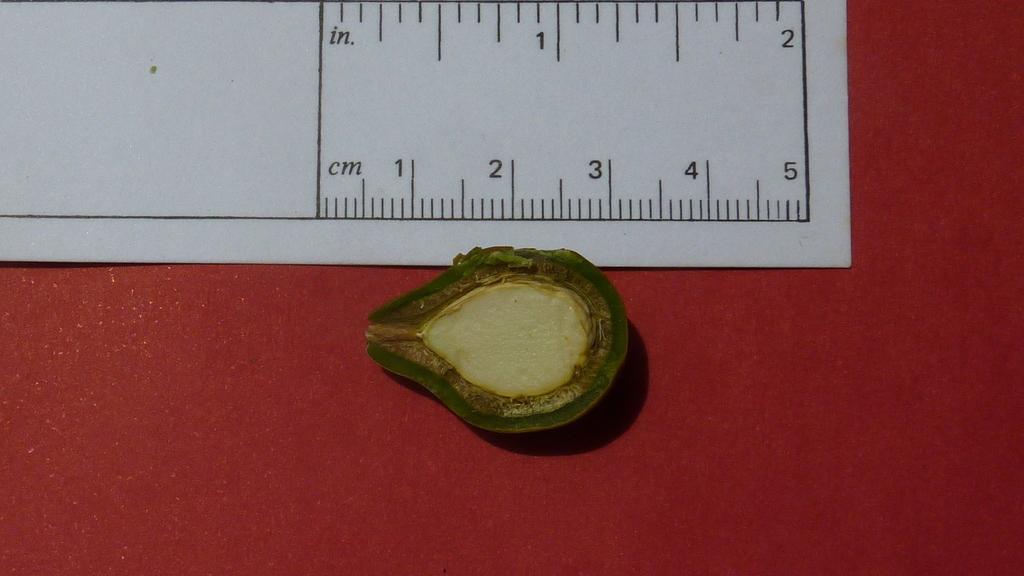Please provide a concise description of this image. This image consists of a paper. And there is avocado in the middle. 